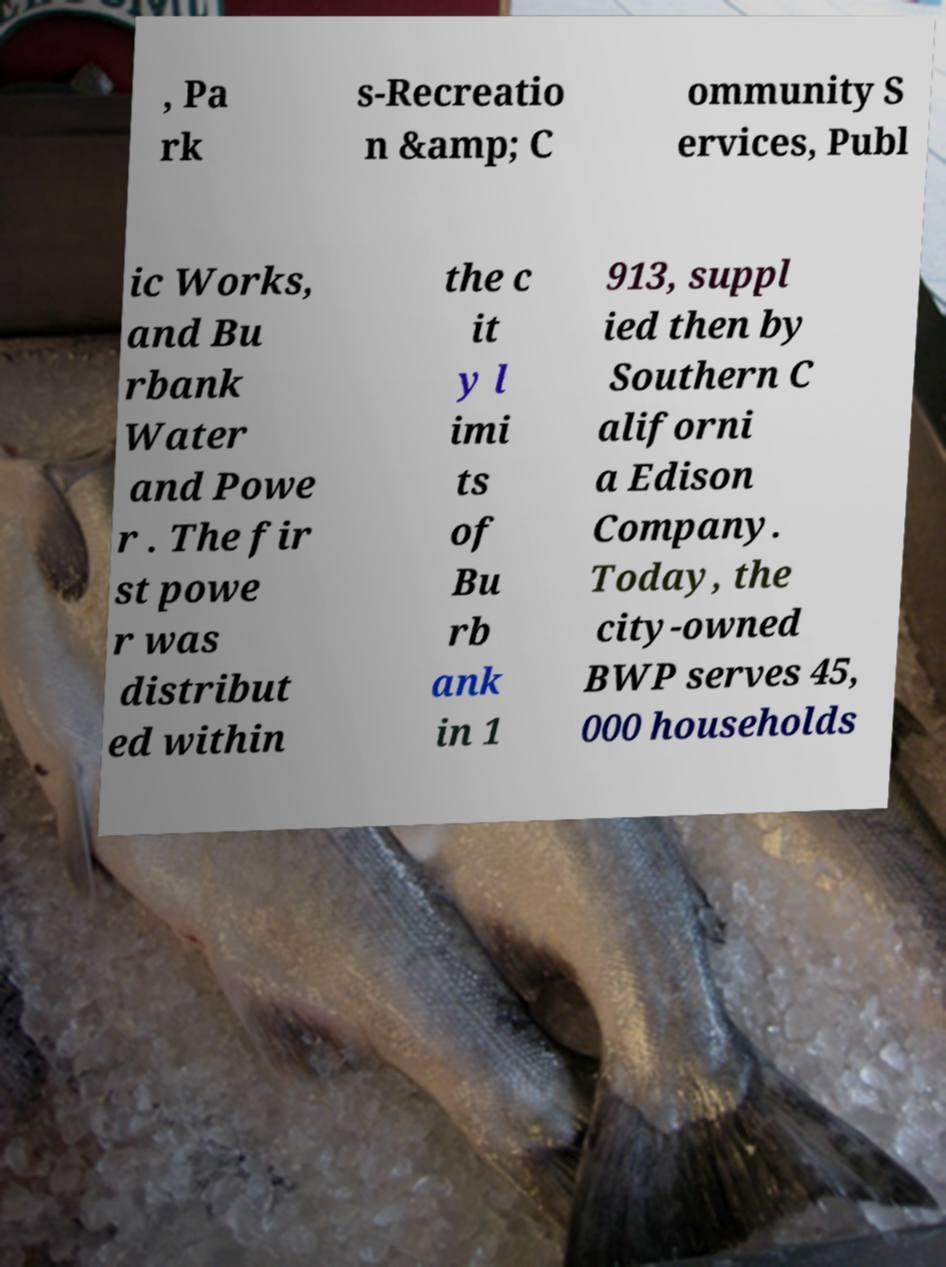Could you assist in decoding the text presented in this image and type it out clearly? , Pa rk s-Recreatio n &amp; C ommunity S ervices, Publ ic Works, and Bu rbank Water and Powe r . The fir st powe r was distribut ed within the c it y l imi ts of Bu rb ank in 1 913, suppl ied then by Southern C aliforni a Edison Company. Today, the city-owned BWP serves 45, 000 households 